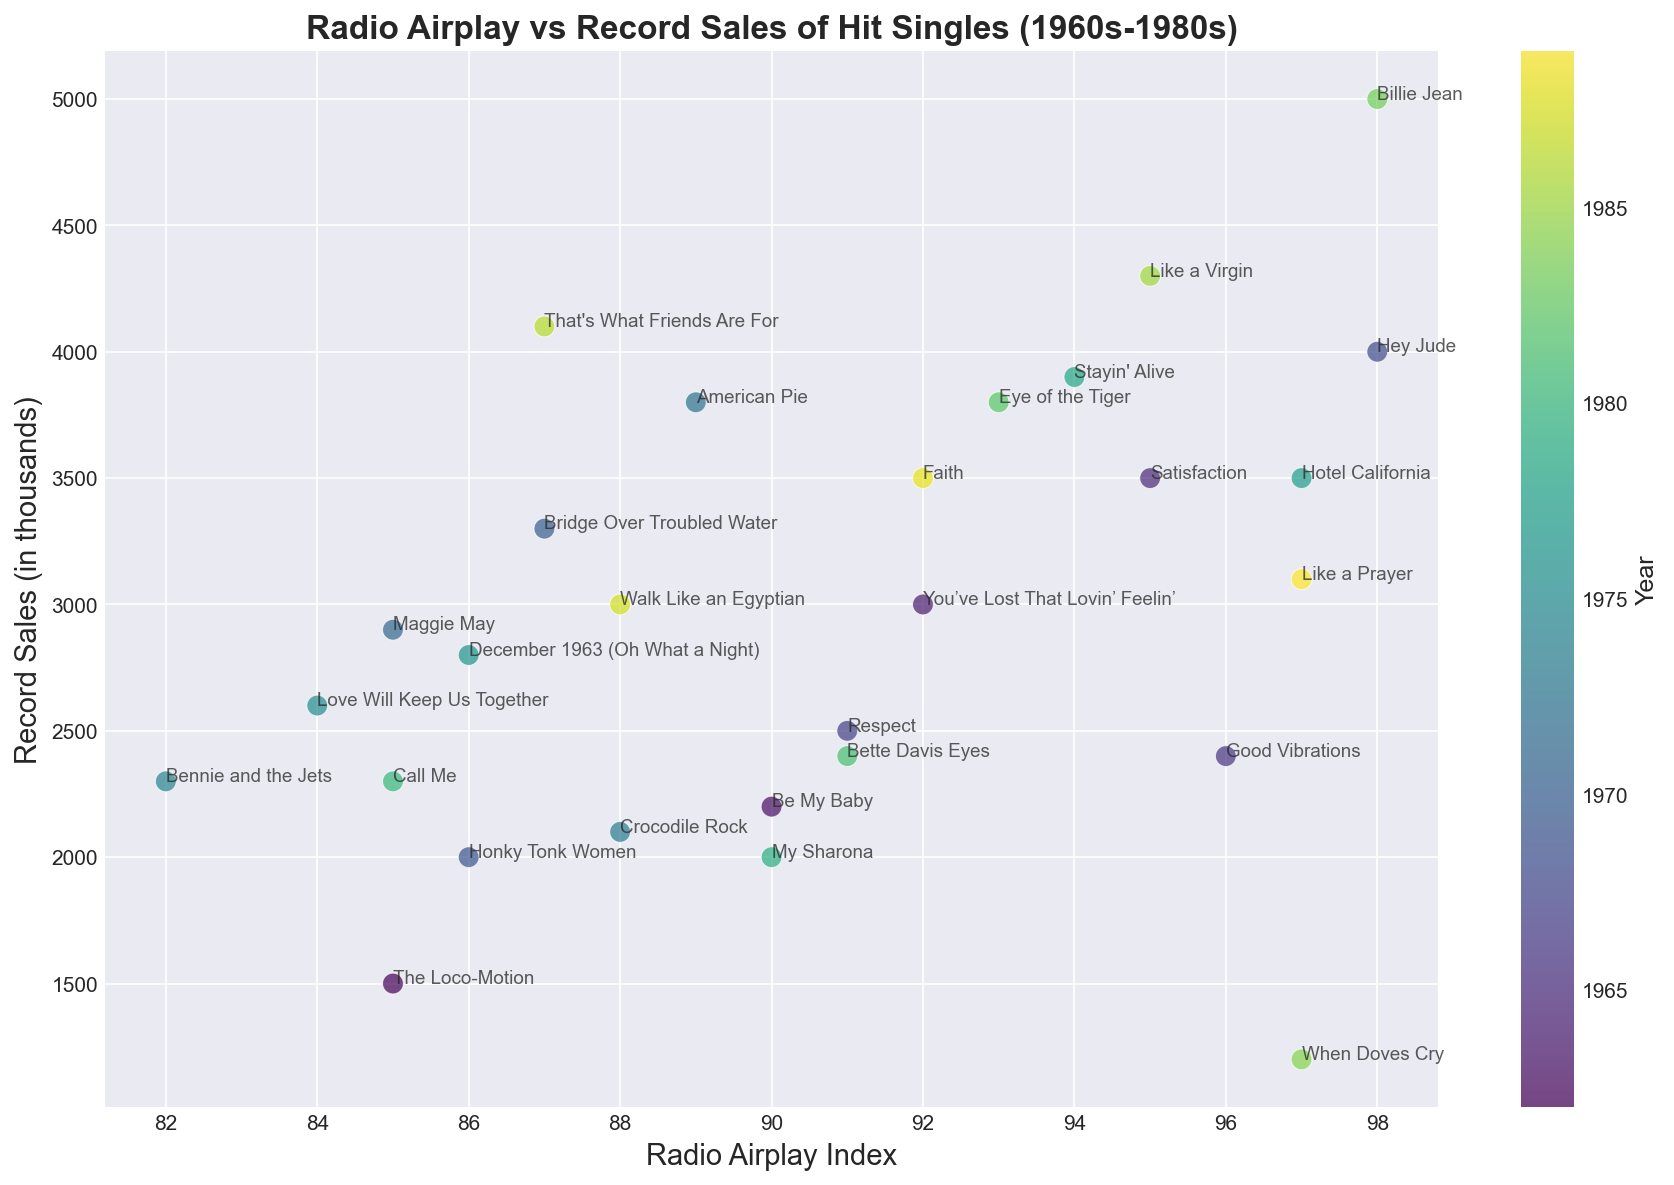Which song from the 1980s had the highest record sales? To determine this, look at the scatter plot points corresponding to the 1980s (the highest end of the color map bar). Compare the position on the y-axis for each point.
Answer: Billie Jean What is the difference in record sales between "Billie Jean" and "When Doves Cry"? Locate "Billie Jean" and "When Doves Cry" on the plot. "Billie Jean" has 5000 thousand in sales, and "When Doves Cry" has 1200 thousand in sales. Subtract the smaller from the larger. 5000 - 1200 = 3800.
Answer: 3800 Which song had the highest radio airplay index in the 1970s? Identify points from the 1970s. Compare the x-axis positions of these points. The song with the highest x-value in that range corresponds to the highest radio airplay index.
Answer: Hotel California Is there a correlation between radio airplay index and record sales? Examine the overall trend of the scatter plot. See if higher radio airplay indices generally result in higher record sales, indicating a correlation.
Answer: Yes Which artist had two hit singles in the 1970s, and what were their records sales? Identify points in the 1970s, look for repeated artist names. Elton John appears twice. The corresponding y-axis values are the record sales: 2100 and 2300.
Answer: Elton John, 2100 and 2300 What is the average record sales for songs with a radio airplay index greater than 95? Identify points with x-axis values greater than 95. Find the y-axis values for these points. Add these values and divide by the number of points. (3500 + 4000 + 3900 + 5000 + 4300 + 3100) / 6 = 3966.67.
Answer: 3966.67 Which song had both a high radio airplay index and low record sales? Look for points with high x-axis values but relatively low y-axis values. "When Doves Cry" stands out with a high radio airplay index (97) and relatively low sales (1200).
Answer: When Doves Cry Which song released in the 1960s had the highest radio airplay index, and how much were its record sales? Focus on points representing songs from the 1960s. Compare their x-axis positions and select the one with the highest value. "Hey Jude" with the highest radio airplay index (98) and 4000 in record sales.
Answer: Hey Jude, 4000 Compare the overall record sales trend between the 1960s and 1980s. Are there more high-selling records in one decade compared to the other? Look at the distribution of points on the y-axis for the 1960s (lower end of the color map bar) vs. the 1980s (higher end of the color map bar). Count and compare the number of points with high y-values in each decade.
Answer: More high-selling records in the 1980s 